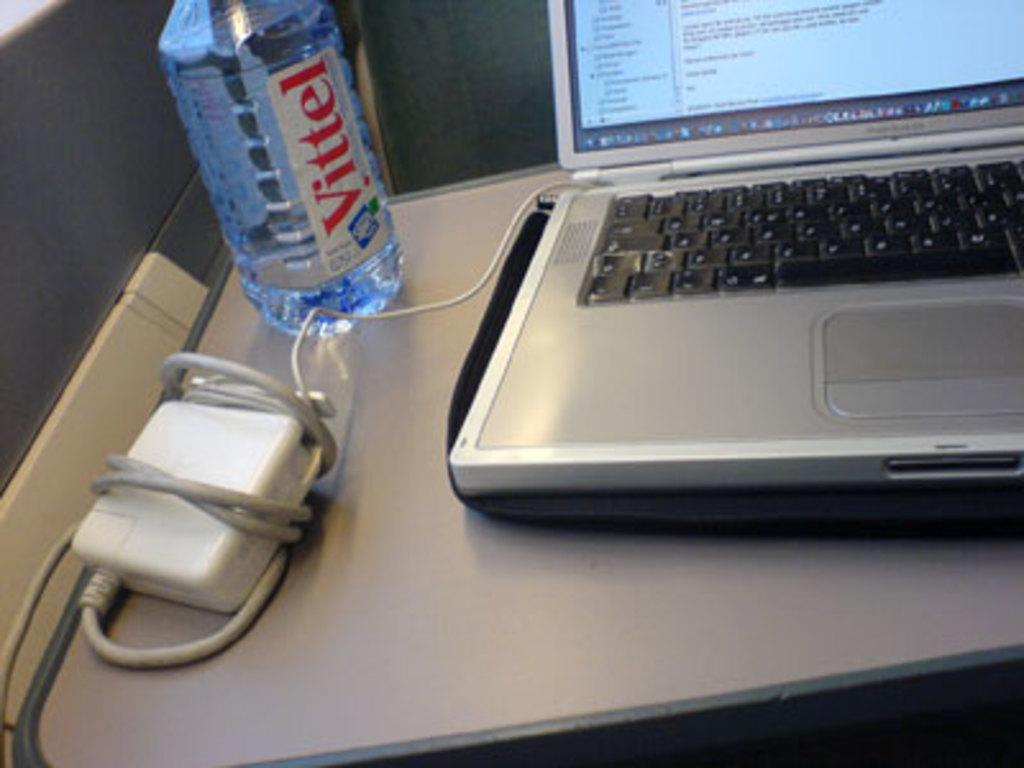<image>
Summarize the visual content of the image. A bottle of Vittel sits next to a computer. 